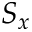<formula> <loc_0><loc_0><loc_500><loc_500>S _ { x }</formula> 